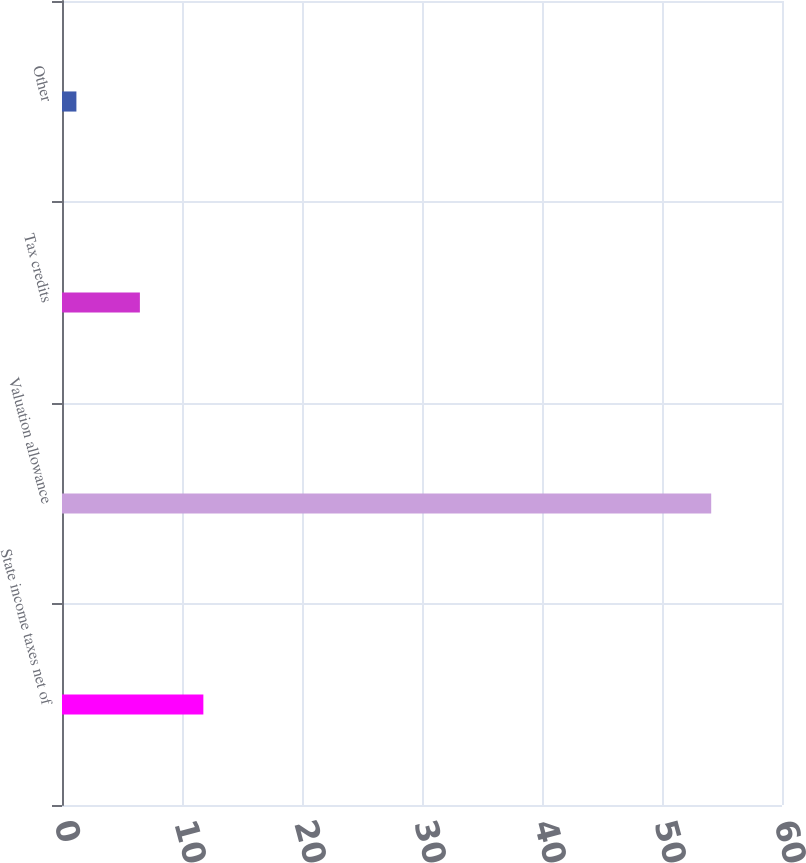<chart> <loc_0><loc_0><loc_500><loc_500><bar_chart><fcel>State income taxes net of<fcel>Valuation allowance<fcel>Tax credits<fcel>Other<nl><fcel>11.78<fcel>54.1<fcel>6.49<fcel>1.2<nl></chart> 